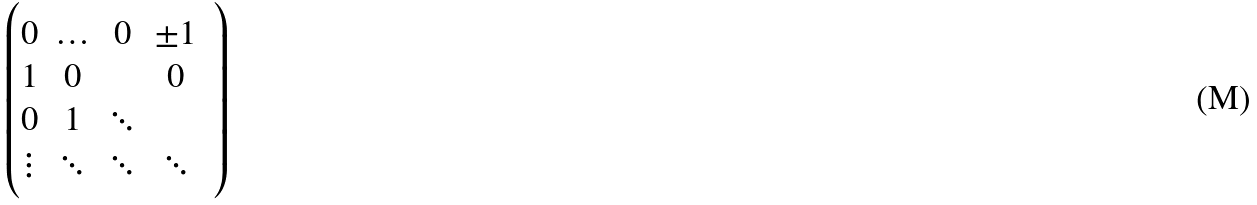<formula> <loc_0><loc_0><loc_500><loc_500>\begin{pmatrix} 0 & \hdots & 0 & \pm 1 \\ 1 & 0 & & 0 \\ 0 & 1 & \ddots & \\ \vdots & \ddots & \ddots & \ddots & \end{pmatrix}</formula> 